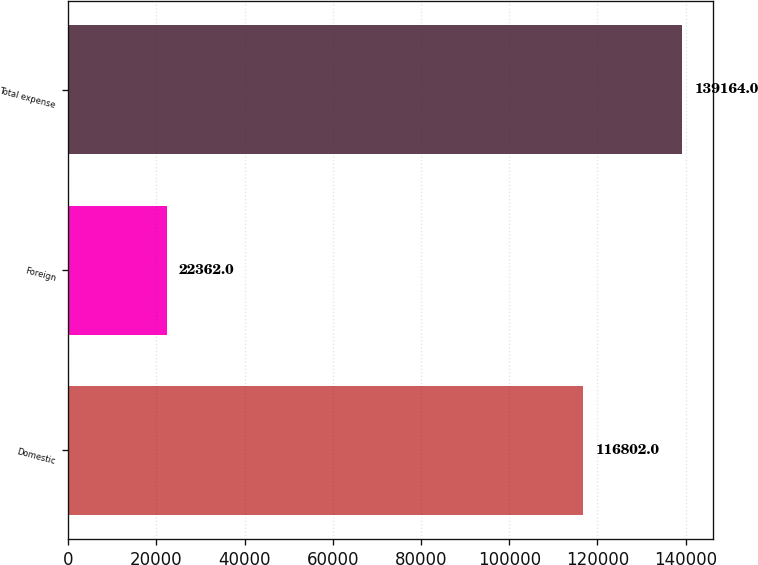<chart> <loc_0><loc_0><loc_500><loc_500><bar_chart><fcel>Domestic<fcel>Foreign<fcel>Total expense<nl><fcel>116802<fcel>22362<fcel>139164<nl></chart> 